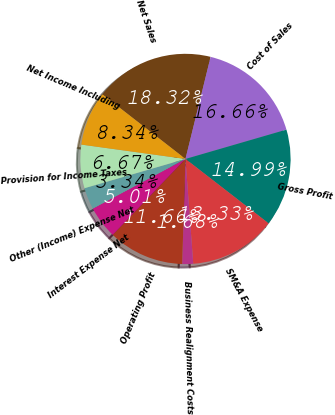Convert chart. <chart><loc_0><loc_0><loc_500><loc_500><pie_chart><fcel>Net Sales<fcel>Cost of Sales<fcel>Gross Profit<fcel>SM&A Expense<fcel>Business Realignment Costs<fcel>Operating Profit<fcel>Interest Expense Net<fcel>Other (Income) Expense Net<fcel>Provision for Income Taxes<fcel>Net Income Including<nl><fcel>18.32%<fcel>16.66%<fcel>14.99%<fcel>13.33%<fcel>1.68%<fcel>11.66%<fcel>5.01%<fcel>3.34%<fcel>6.67%<fcel>8.34%<nl></chart> 